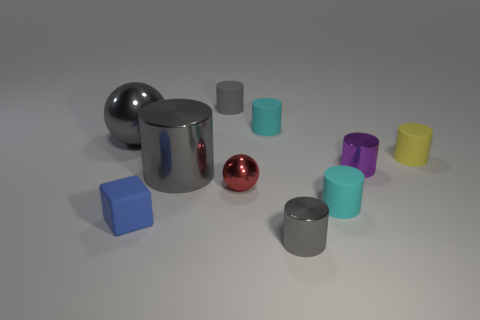How many cyan cylinders must be subtracted to get 1 cyan cylinders? 1 Subtract all cyan cylinders. How many cylinders are left? 5 Subtract all large gray cylinders. How many cylinders are left? 6 Subtract 0 brown cylinders. How many objects are left? 10 Subtract all blocks. How many objects are left? 9 Subtract 6 cylinders. How many cylinders are left? 1 Subtract all green cylinders. Subtract all yellow blocks. How many cylinders are left? 7 Subtract all blue blocks. How many purple cylinders are left? 1 Subtract all gray cylinders. Subtract all small cyan matte objects. How many objects are left? 5 Add 3 small red balls. How many small red balls are left? 4 